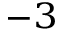<formula> <loc_0><loc_0><loc_500><loc_500>^ { - 3 }</formula> 